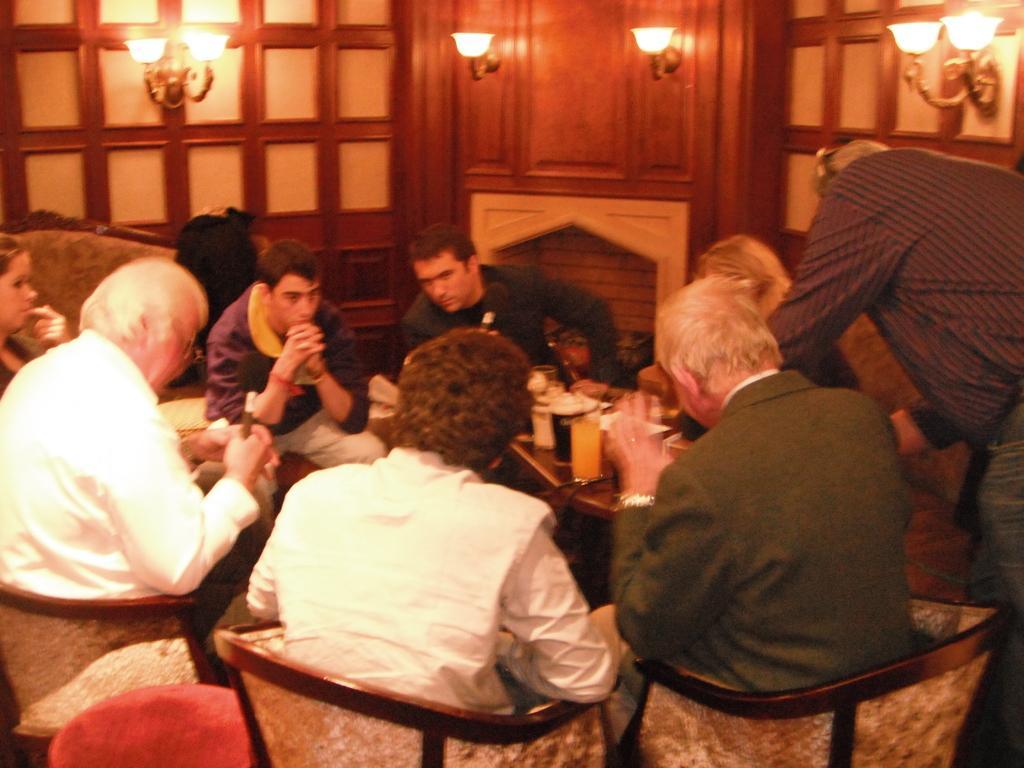Can you describe this image briefly? In this image I can see the group of people sitting in-front of the table and one person standing. On the table I can see many glasses. In the background I can see the fireplace and many lights. 